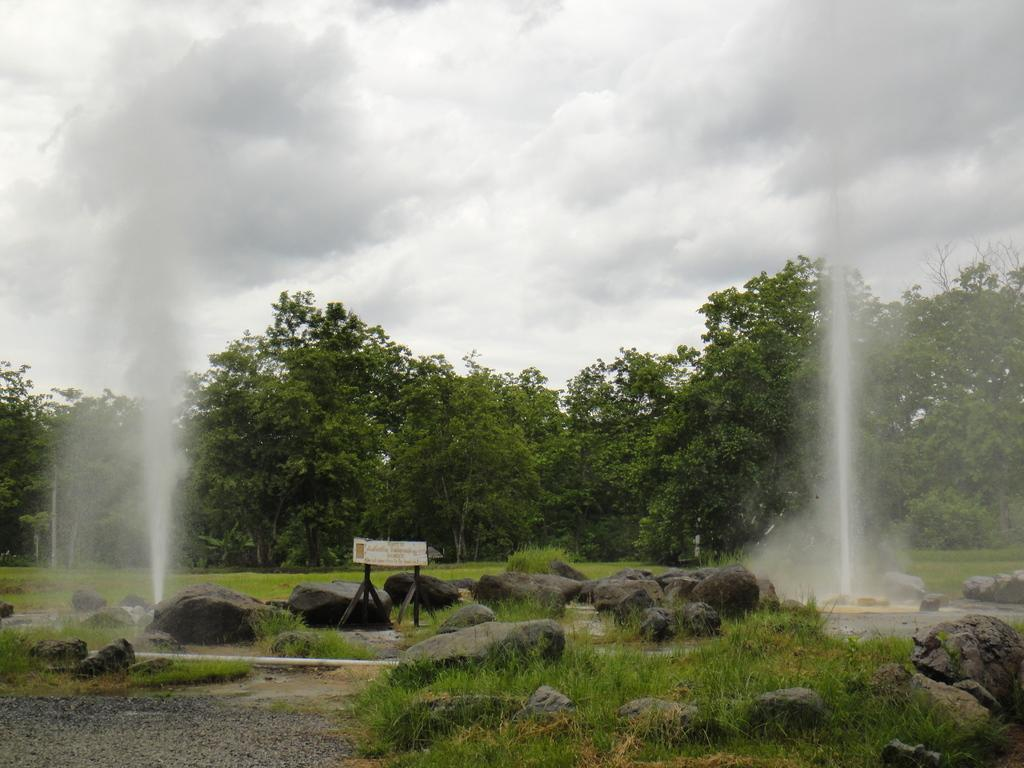What type of natural elements can be seen in the image? There are rocks and grass in the image. What man-made object is present in the image? There is a board in the image. What type of water feature can be seen in the image? There are fountains in the image. What type of vegetation is present at the back of the image? Trees are present at the back of the image. What type of joke is being told by the rocks in the image? There are no jokes being told in the image, as rocks are inanimate objects and cannot speak or tell jokes. 